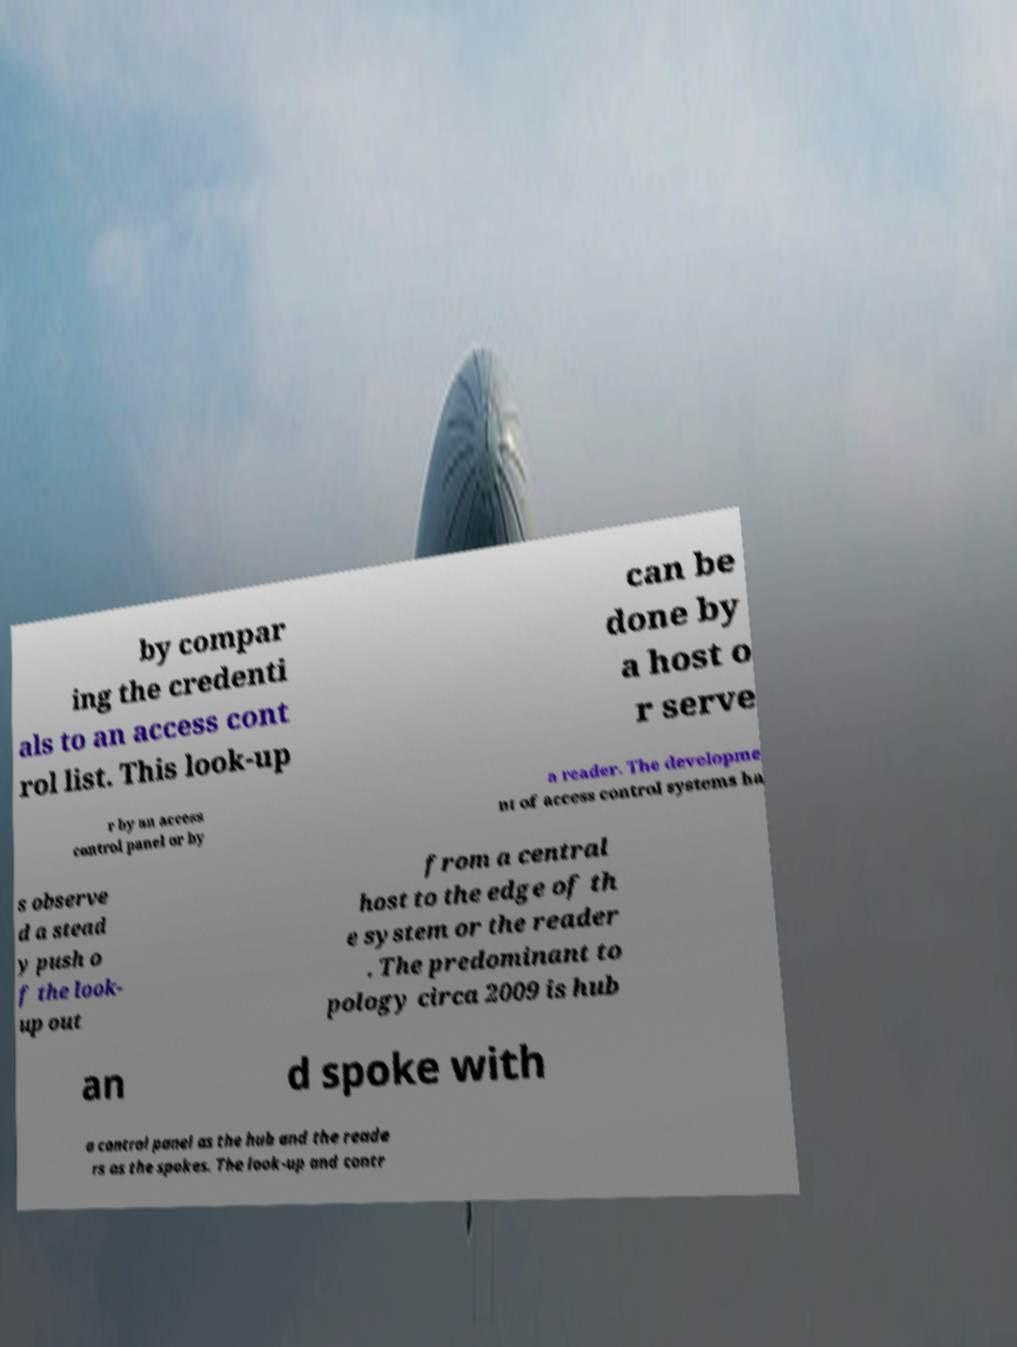Could you assist in decoding the text presented in this image and type it out clearly? by compar ing the credenti als to an access cont rol list. This look-up can be done by a host o r serve r by an access control panel or by a reader. The developme nt of access control systems ha s observe d a stead y push o f the look- up out from a central host to the edge of th e system or the reader . The predominant to pology circa 2009 is hub an d spoke with a control panel as the hub and the reade rs as the spokes. The look-up and contr 